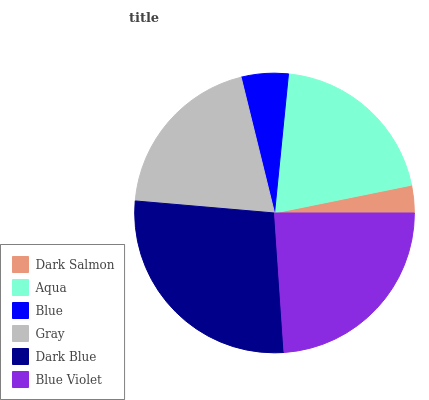Is Dark Salmon the minimum?
Answer yes or no. Yes. Is Dark Blue the maximum?
Answer yes or no. Yes. Is Aqua the minimum?
Answer yes or no. No. Is Aqua the maximum?
Answer yes or no. No. Is Aqua greater than Dark Salmon?
Answer yes or no. Yes. Is Dark Salmon less than Aqua?
Answer yes or no. Yes. Is Dark Salmon greater than Aqua?
Answer yes or no. No. Is Aqua less than Dark Salmon?
Answer yes or no. No. Is Aqua the high median?
Answer yes or no. Yes. Is Gray the low median?
Answer yes or no. Yes. Is Blue the high median?
Answer yes or no. No. Is Blue the low median?
Answer yes or no. No. 